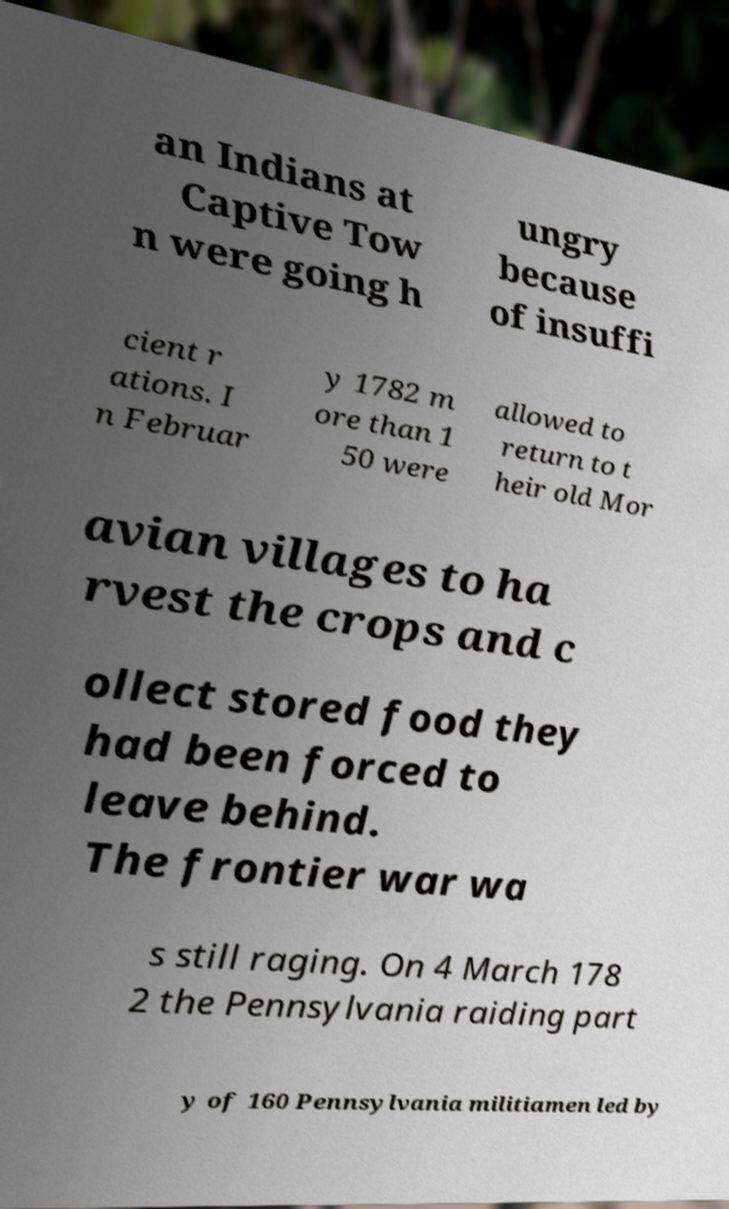Please identify and transcribe the text found in this image. an Indians at Captive Tow n were going h ungry because of insuffi cient r ations. I n Februar y 1782 m ore than 1 50 were allowed to return to t heir old Mor avian villages to ha rvest the crops and c ollect stored food they had been forced to leave behind. The frontier war wa s still raging. On 4 March 178 2 the Pennsylvania raiding part y of 160 Pennsylvania militiamen led by 